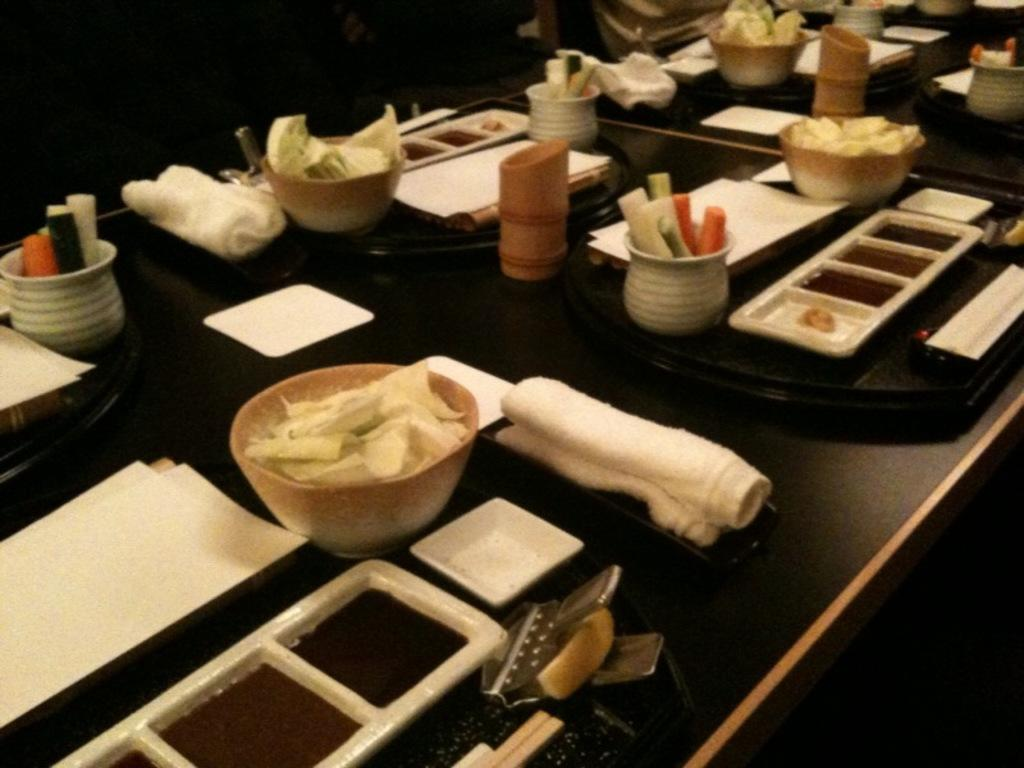What is located in the foreground of the picture? There is a table in the foreground of the picture. What items can be seen on the table? There are bowls, plates, spoons, tissues, towels, food items, and glasses on the table. How many types of tableware are present on the table? There are spoons, plates, and bowls present on the table. What might be used for cleaning or wiping on the table? Tissues and towels are present on the table for cleaning or wiping. What can be used for drinking on the table? Glasses are present on the table for drinking. What type of alarm is present on the table in the image? There is no alarm present on the table in the image. What kind of ticket can be seen on the table in the image? There is no ticket present on the table in the image. 